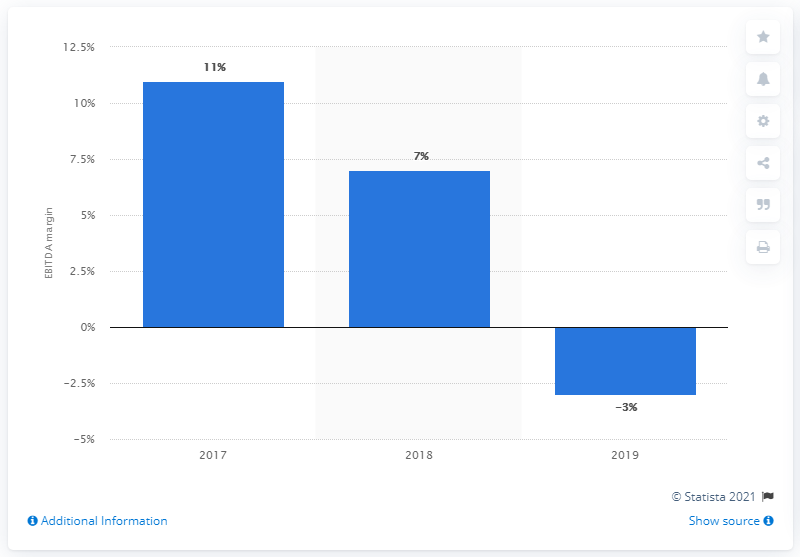Give some essential details in this illustration. In 2017, Dolce & Gabbana S.r.l. reported an EBITDA margin of less than three percent. 